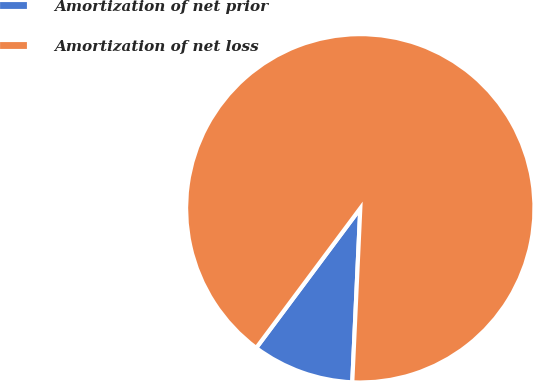Convert chart to OTSL. <chart><loc_0><loc_0><loc_500><loc_500><pie_chart><fcel>Amortization of net prior<fcel>Amortization of net loss<nl><fcel>9.46%<fcel>90.54%<nl></chart> 